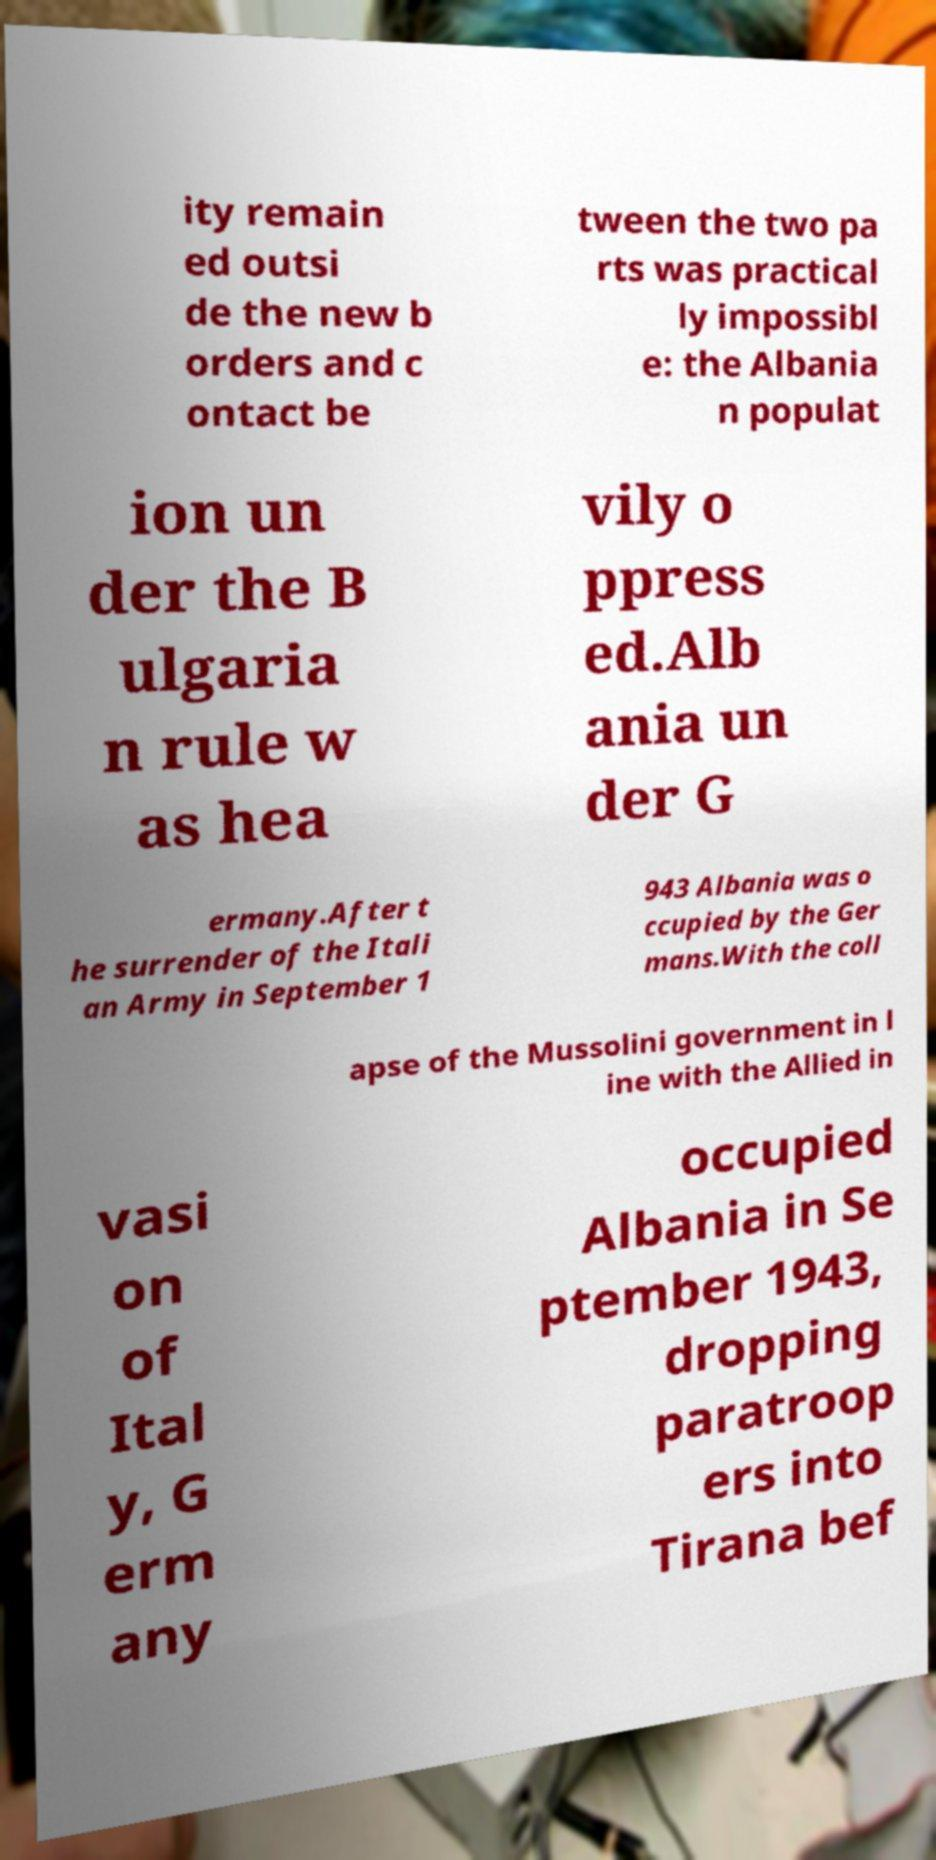What messages or text are displayed in this image? I need them in a readable, typed format. ity remain ed outsi de the new b orders and c ontact be tween the two pa rts was practical ly impossibl e: the Albania n populat ion un der the B ulgaria n rule w as hea vily o ppress ed.Alb ania un der G ermany.After t he surrender of the Itali an Army in September 1 943 Albania was o ccupied by the Ger mans.With the coll apse of the Mussolini government in l ine with the Allied in vasi on of Ital y, G erm any occupied Albania in Se ptember 1943, dropping paratroop ers into Tirana bef 